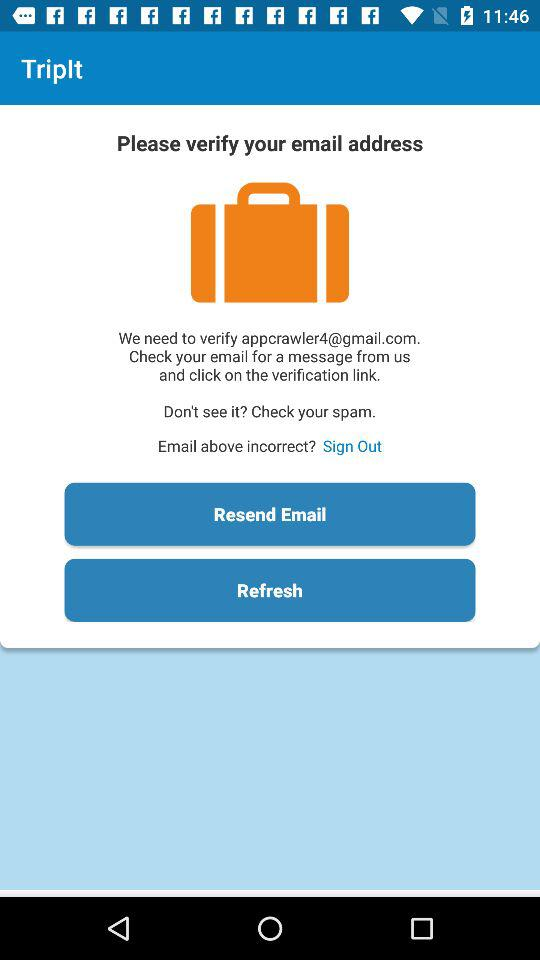What is the application name? The application name is "TripIt". 